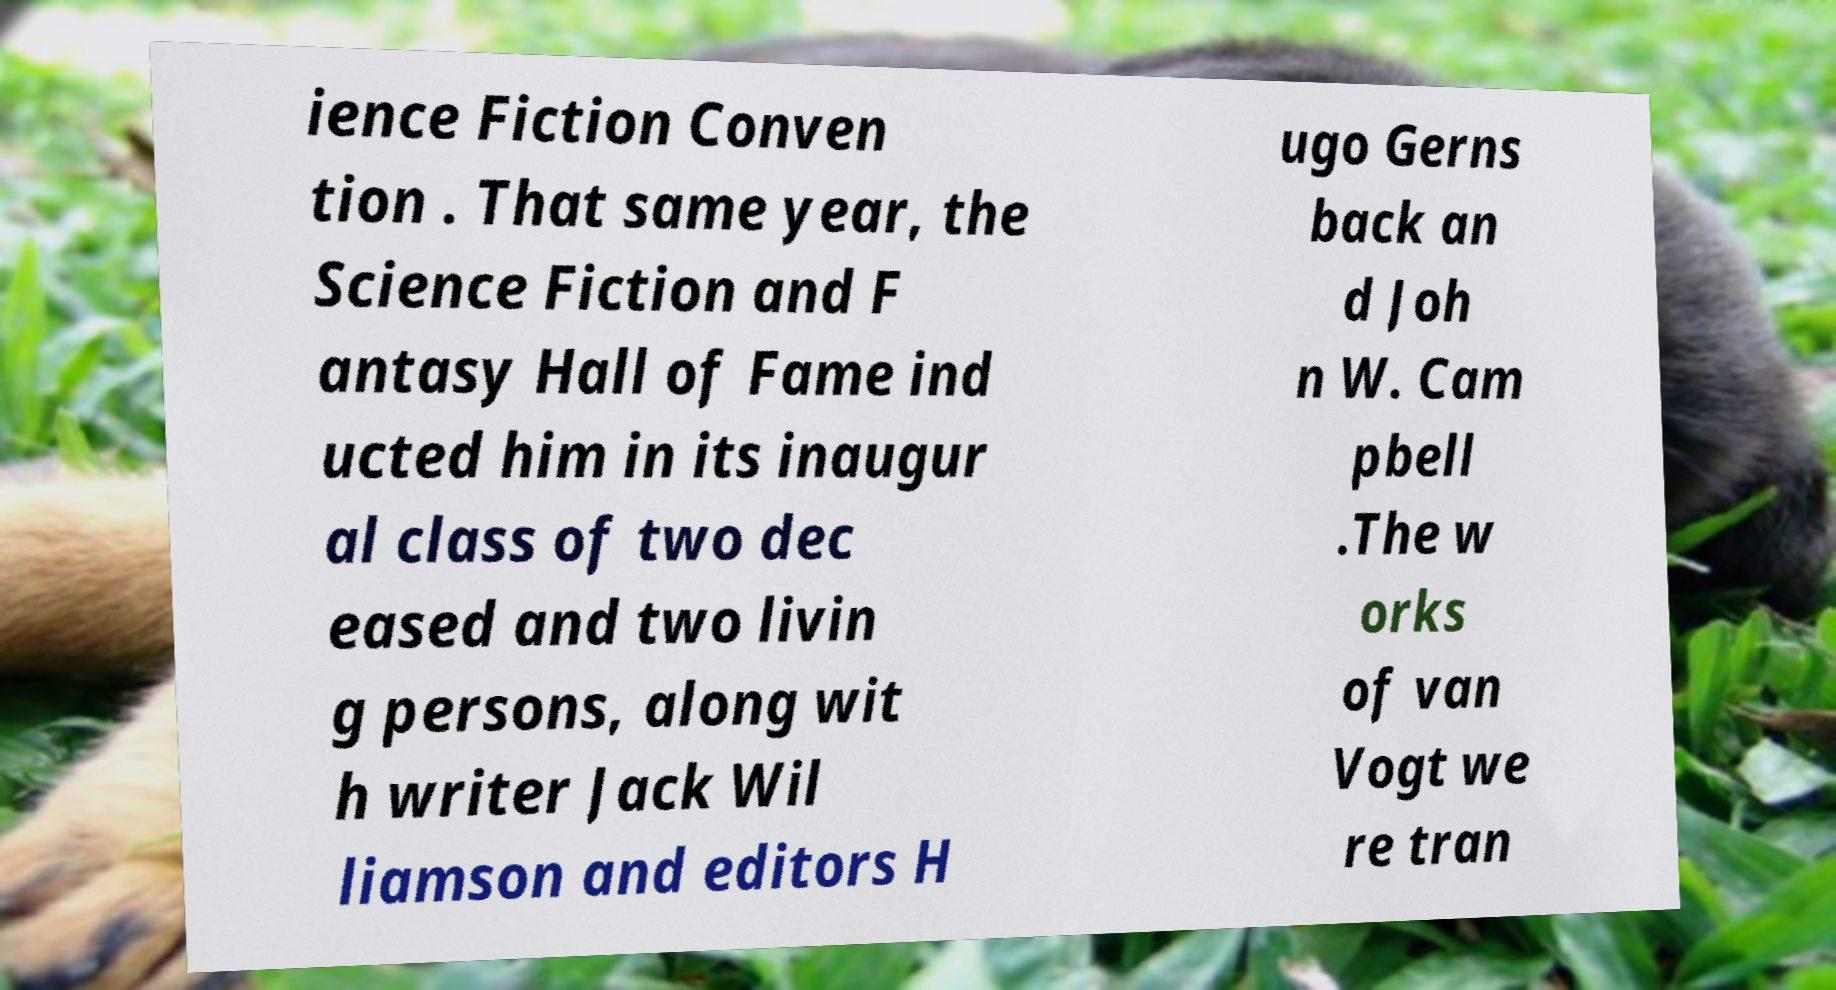There's text embedded in this image that I need extracted. Can you transcribe it verbatim? ience Fiction Conven tion . That same year, the Science Fiction and F antasy Hall of Fame ind ucted him in its inaugur al class of two dec eased and two livin g persons, along wit h writer Jack Wil liamson and editors H ugo Gerns back an d Joh n W. Cam pbell .The w orks of van Vogt we re tran 